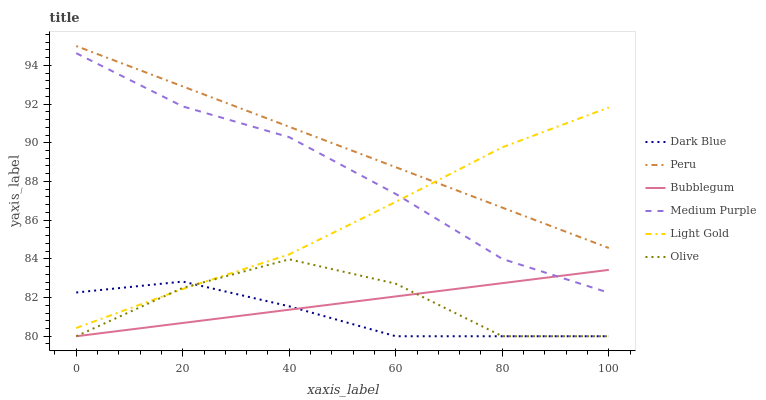Does Dark Blue have the minimum area under the curve?
Answer yes or no. Yes. Does Peru have the maximum area under the curve?
Answer yes or no. Yes. Does Medium Purple have the minimum area under the curve?
Answer yes or no. No. Does Medium Purple have the maximum area under the curve?
Answer yes or no. No. Is Peru the smoothest?
Answer yes or no. Yes. Is Olive the roughest?
Answer yes or no. Yes. Is Medium Purple the smoothest?
Answer yes or no. No. Is Medium Purple the roughest?
Answer yes or no. No. Does Bubblegum have the lowest value?
Answer yes or no. Yes. Does Medium Purple have the lowest value?
Answer yes or no. No. Does Peru have the highest value?
Answer yes or no. Yes. Does Medium Purple have the highest value?
Answer yes or no. No. Is Medium Purple less than Peru?
Answer yes or no. Yes. Is Peru greater than Bubblegum?
Answer yes or no. Yes. Does Olive intersect Light Gold?
Answer yes or no. Yes. Is Olive less than Light Gold?
Answer yes or no. No. Is Olive greater than Light Gold?
Answer yes or no. No. Does Medium Purple intersect Peru?
Answer yes or no. No. 